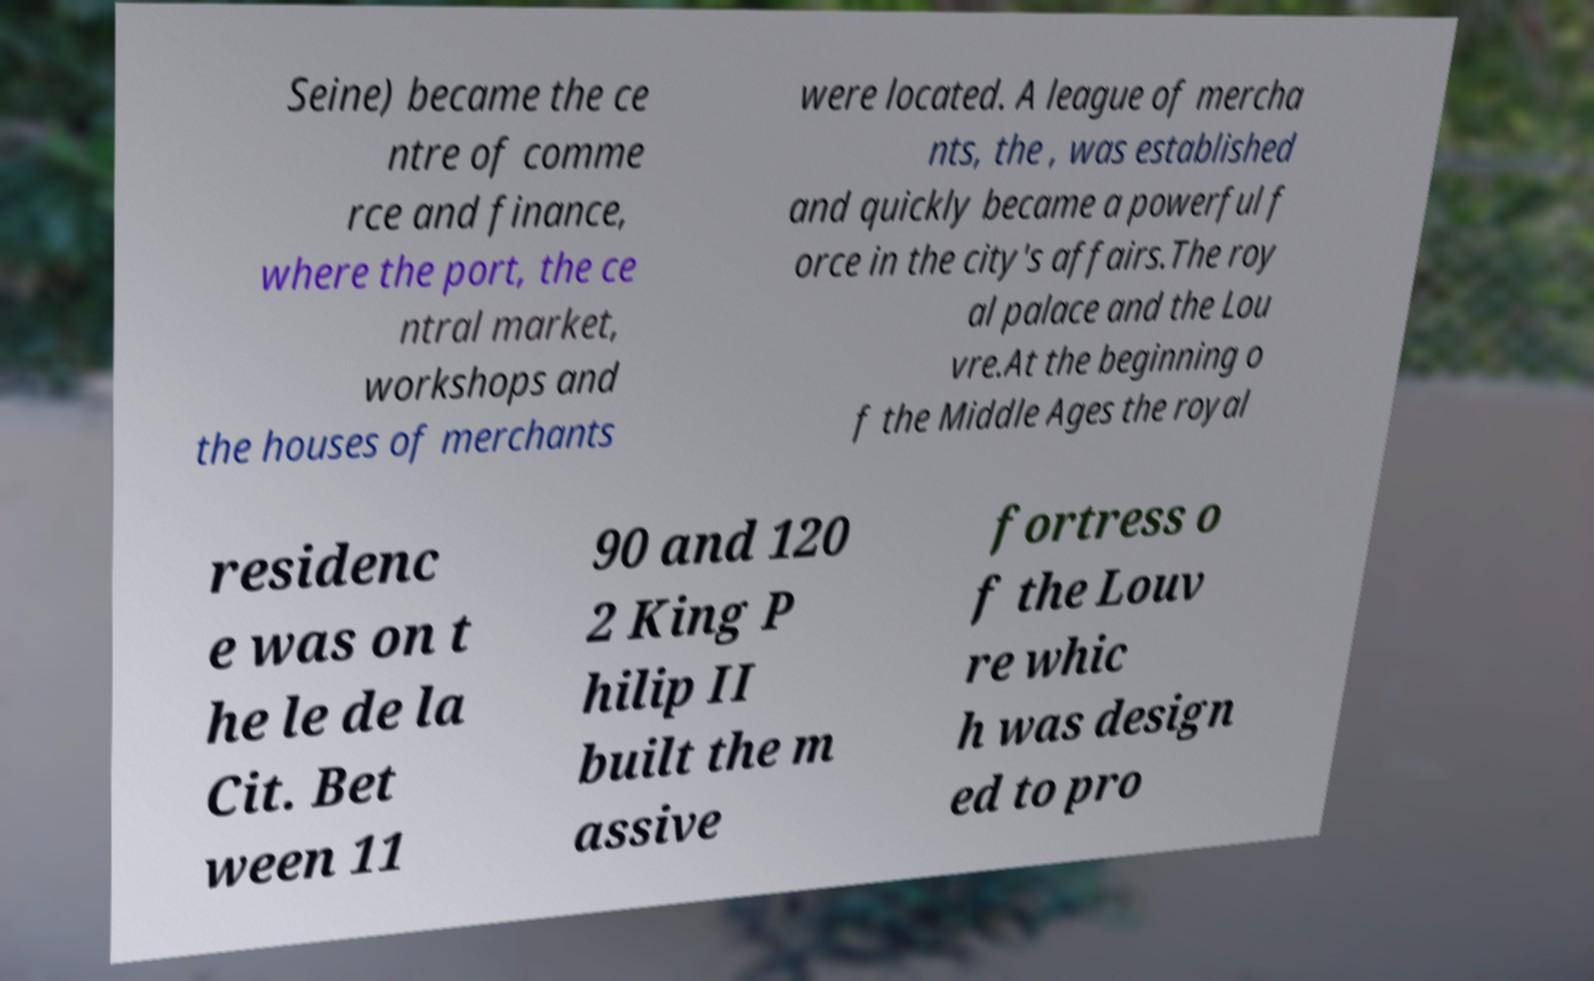Please read and relay the text visible in this image. What does it say? Seine) became the ce ntre of comme rce and finance, where the port, the ce ntral market, workshops and the houses of merchants were located. A league of mercha nts, the , was established and quickly became a powerful f orce in the city's affairs.The roy al palace and the Lou vre.At the beginning o f the Middle Ages the royal residenc e was on t he le de la Cit. Bet ween 11 90 and 120 2 King P hilip II built the m assive fortress o f the Louv re whic h was design ed to pro 